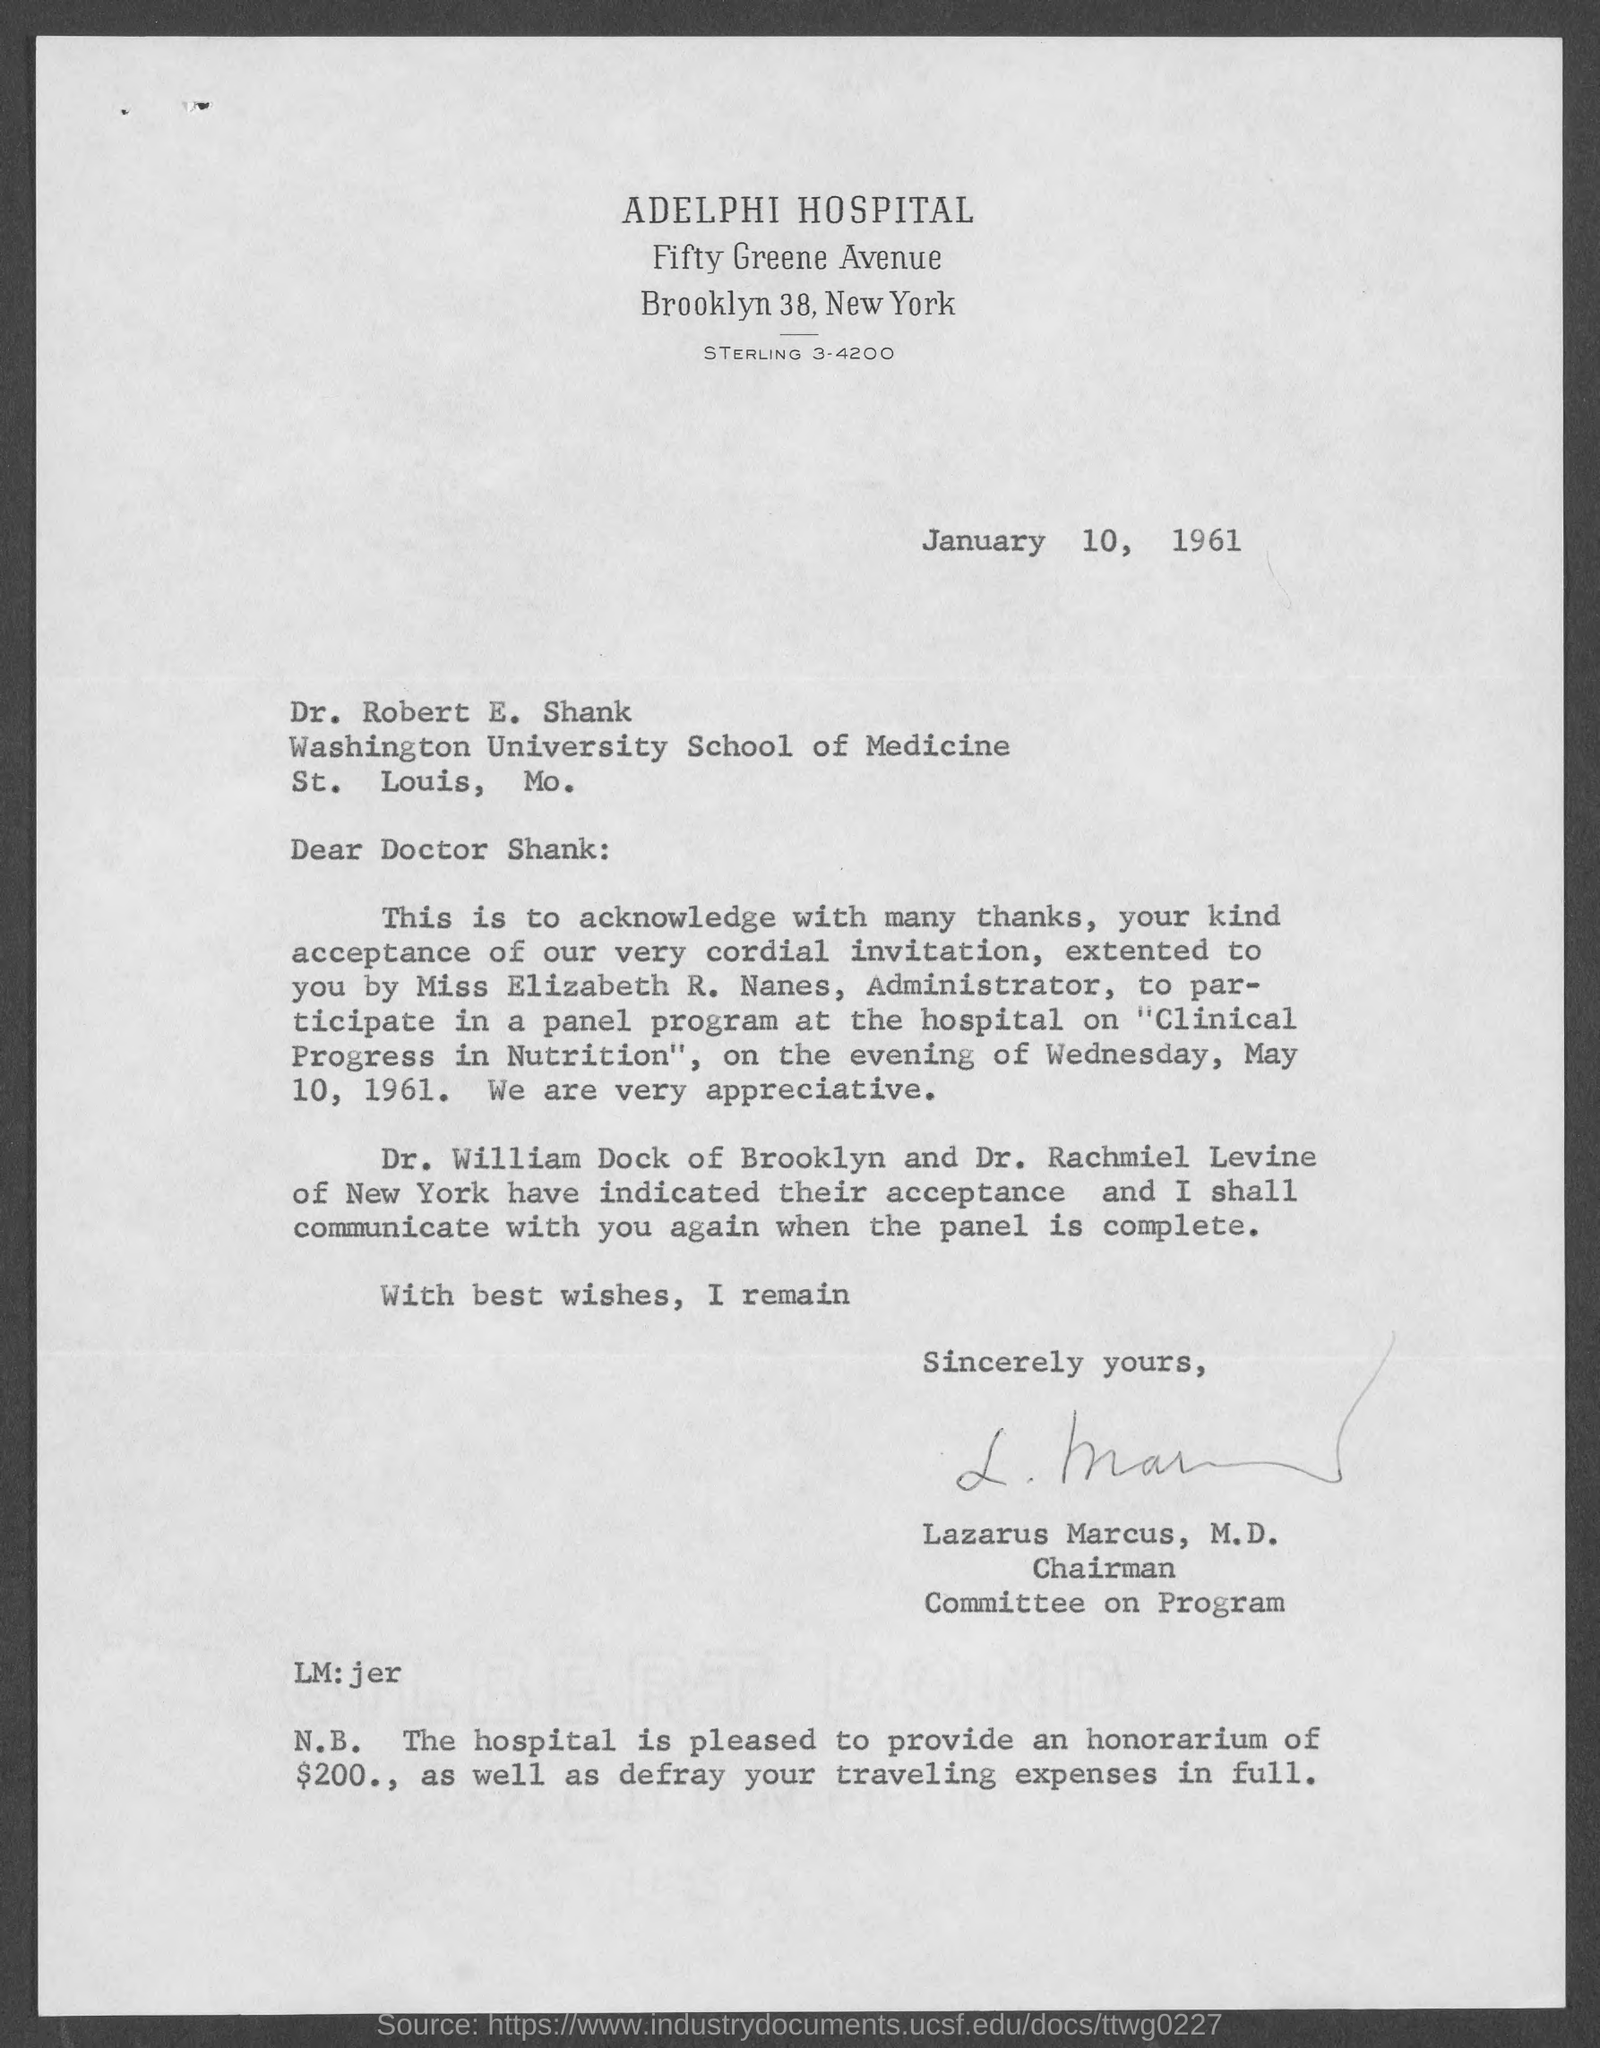List a handful of essential elements in this visual. The hospital is pleased to provide an honorarium of $200 to Dr. Robert E. Shank. Lazarus Marcus, M.D., is the chairman of the Committee on Program. This letter is addressed to Dr. Robert E. Shank. The invitation is for Wednesday. The address of Washington University School of Medicine is located in St. Louis, Missouri. 